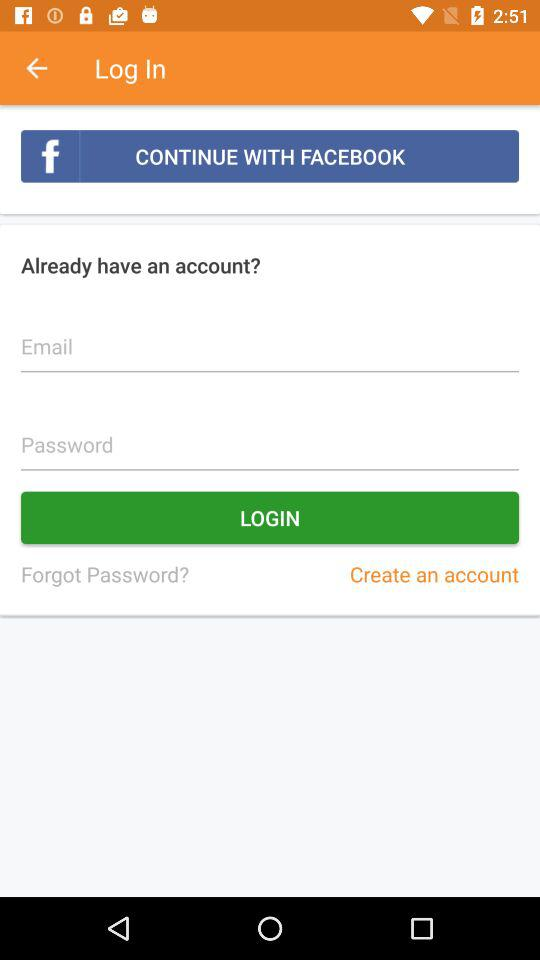Which account can I use to log in? The accounts you can use to log in are "FACEBOOK" and "Email". 